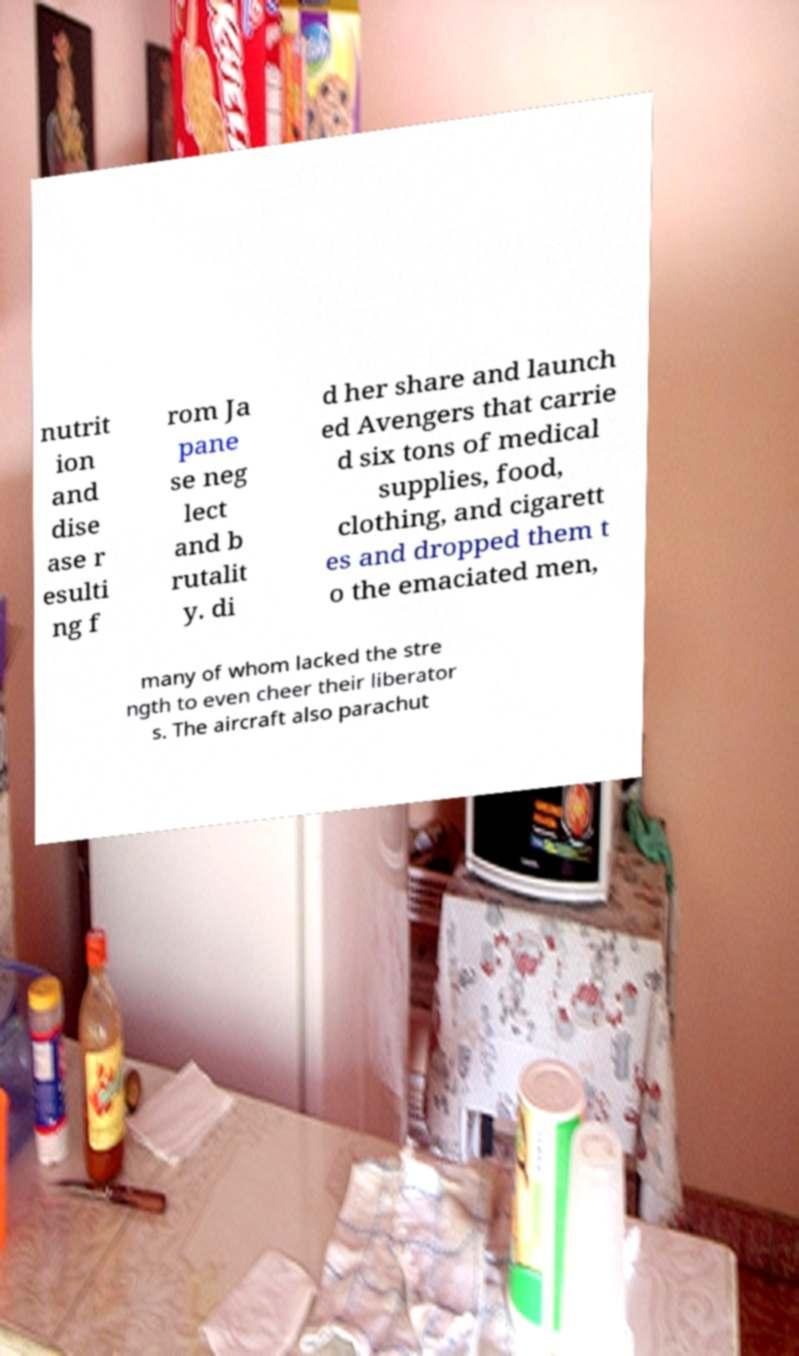What messages or text are displayed in this image? I need them in a readable, typed format. nutrit ion and dise ase r esulti ng f rom Ja pane se neg lect and b rutalit y. di d her share and launch ed Avengers that carrie d six tons of medical supplies, food, clothing, and cigarett es and dropped them t o the emaciated men, many of whom lacked the stre ngth to even cheer their liberator s. The aircraft also parachut 